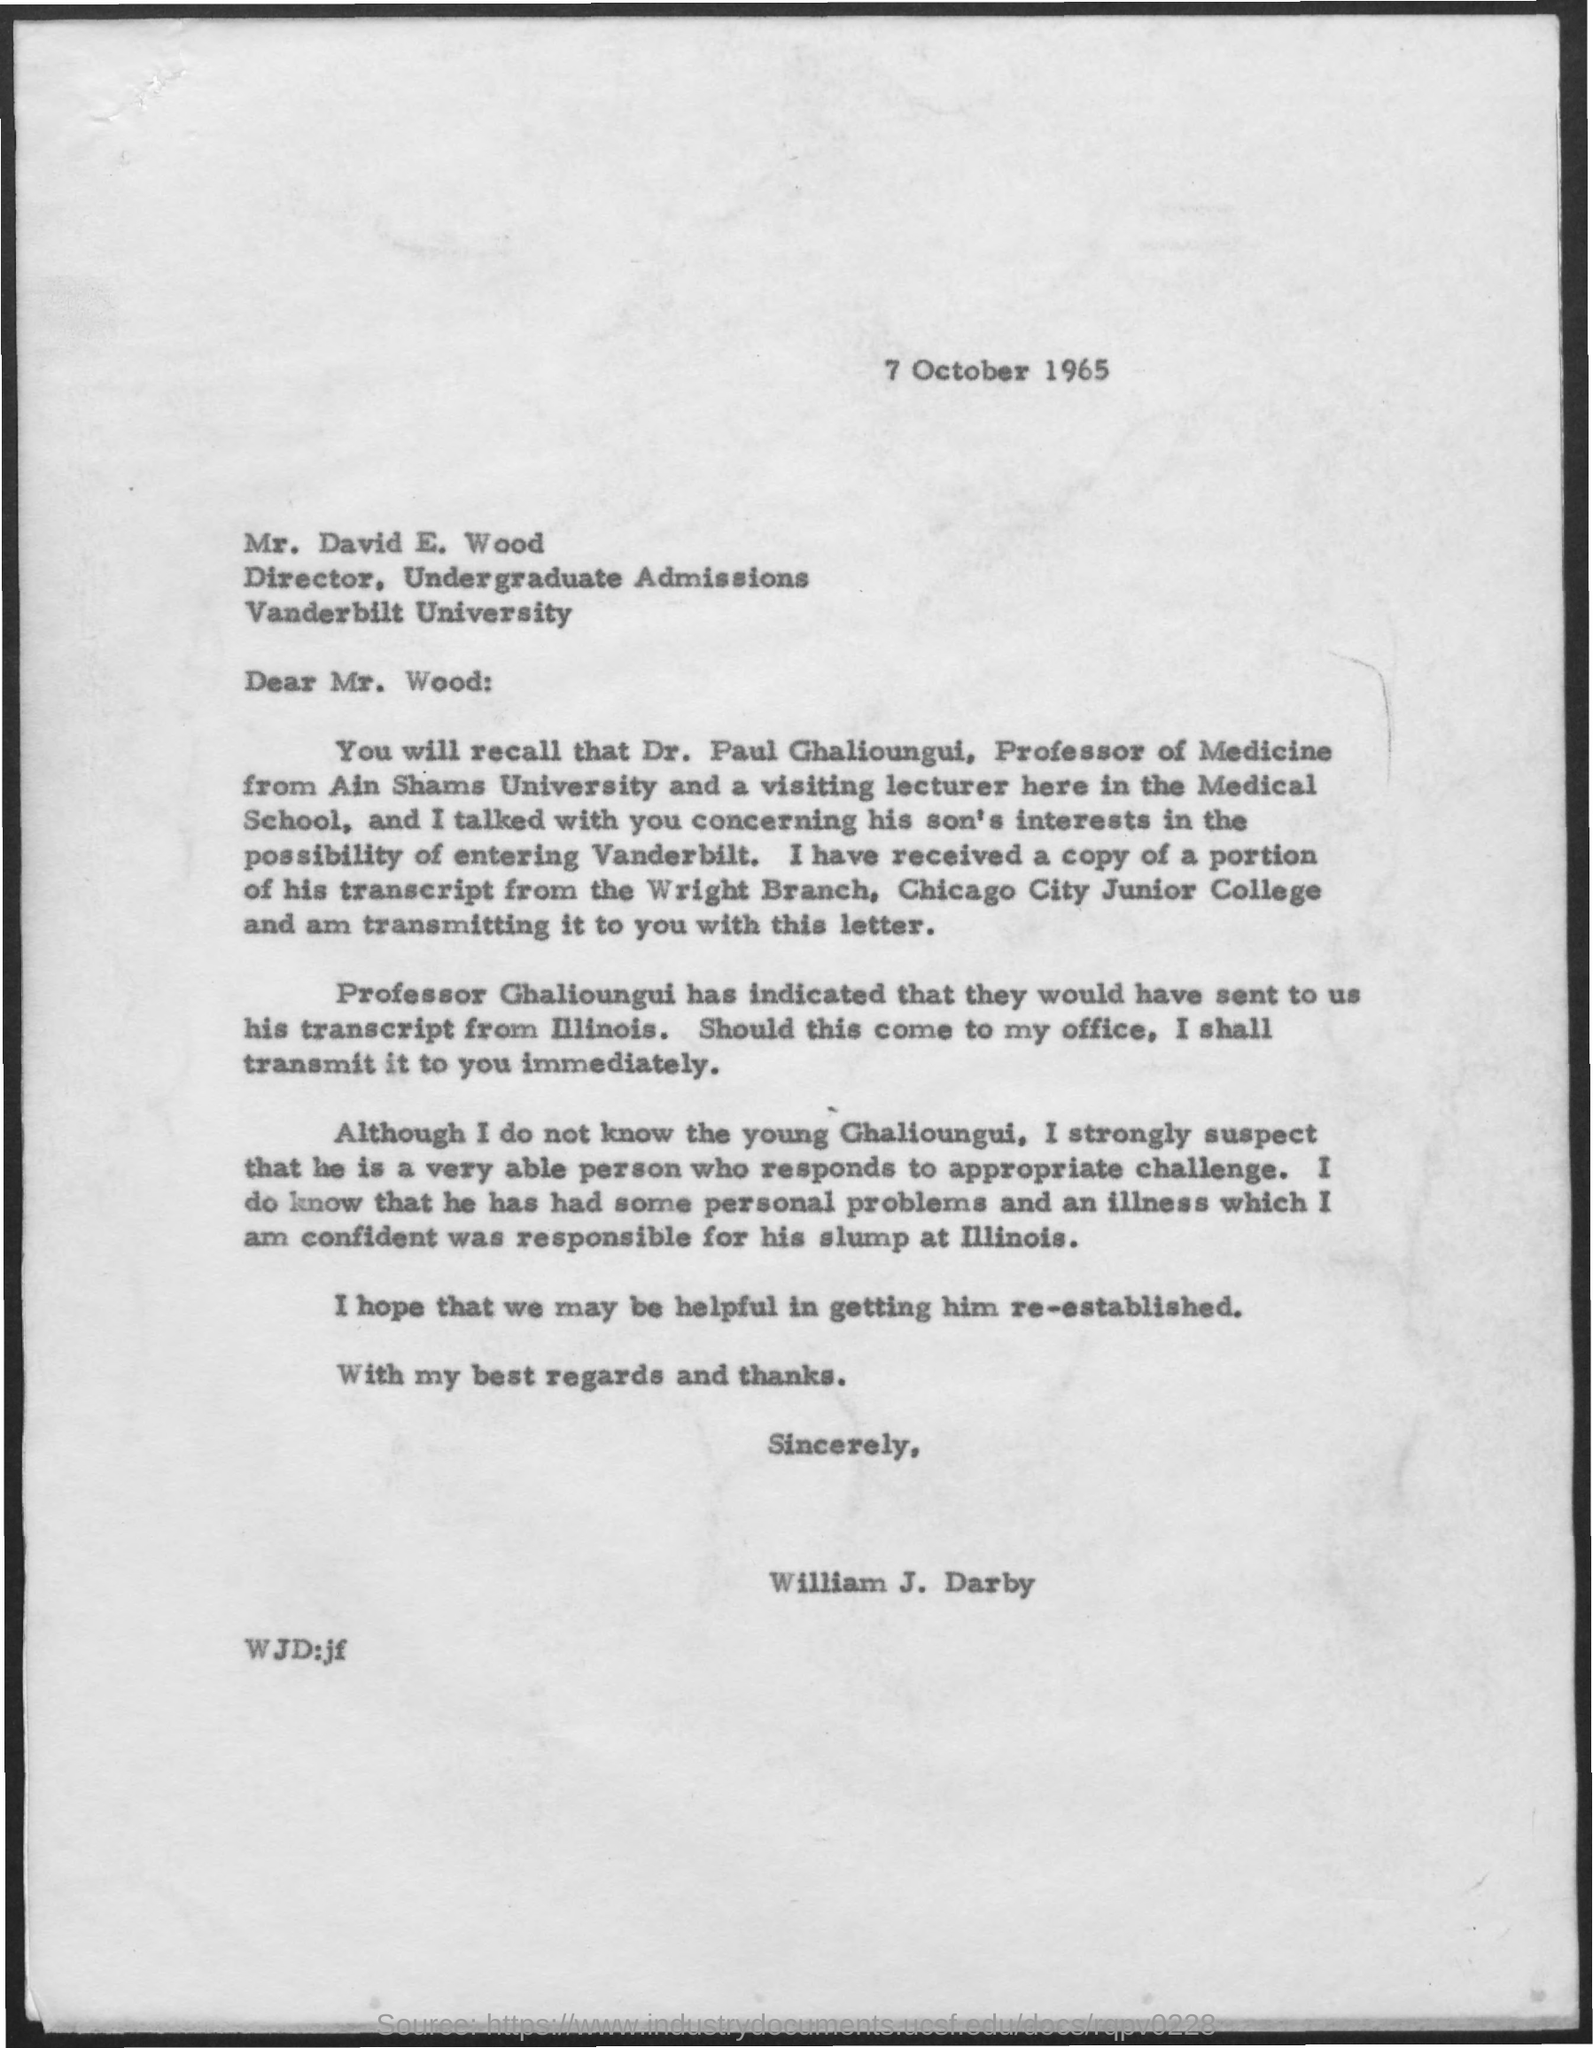Point out several critical features in this image. The letter is addressed to Mr. David E. Wood. Mr. David's designation is Director. The letter is dated October 7, 1965. The letter is from William J. Darby. 